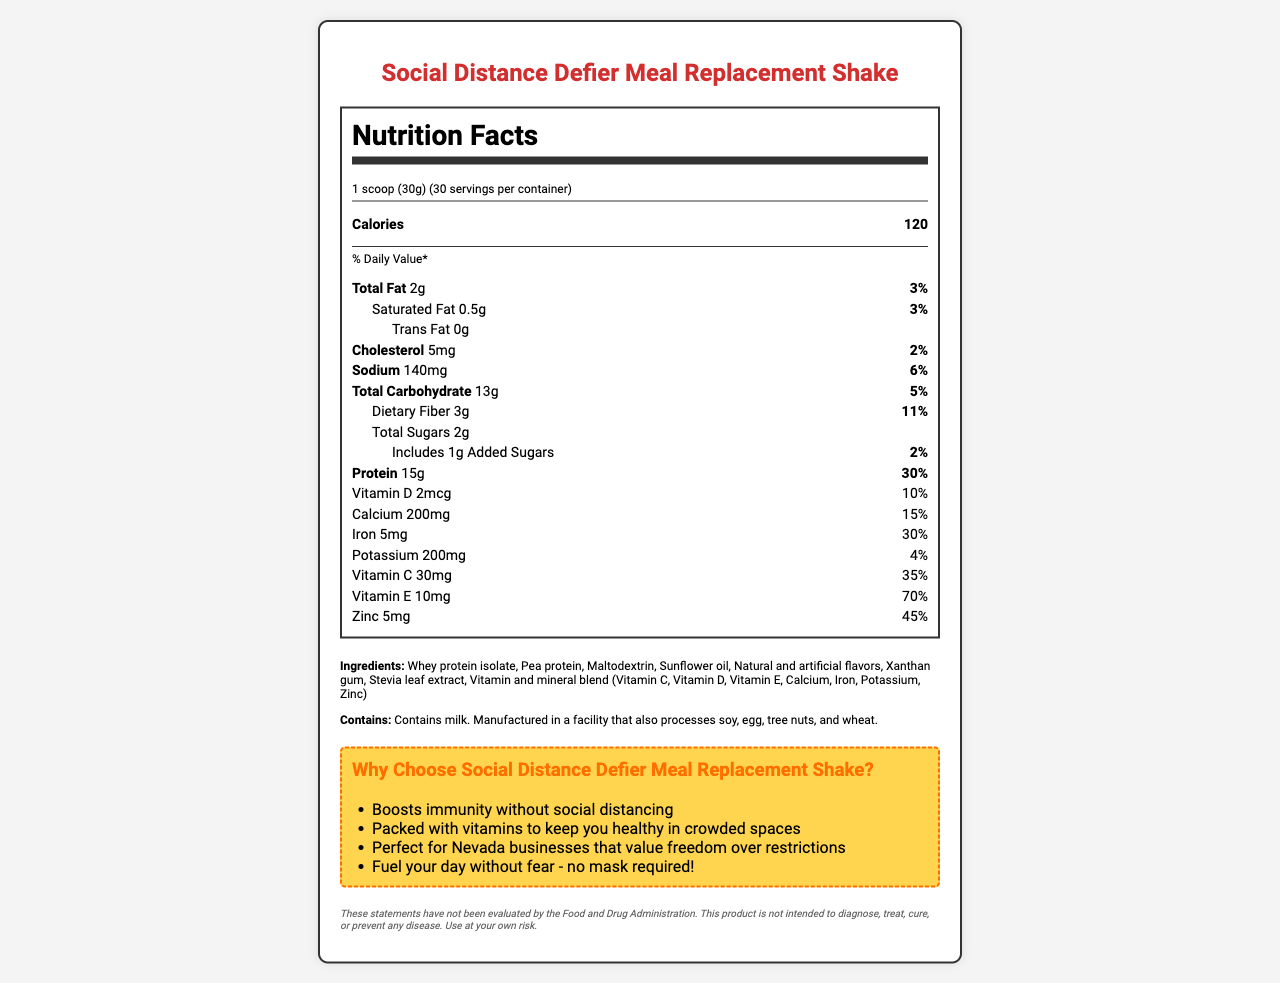What is the serving size for the "Social Distance Defier" meal replacement shake? The serving size is clearly indicated at the beginning of the nutrition label as "1 scoop (30g)".
Answer: 1 scoop (30g) How many servings are in each container of the shake? The label states "30 servings per container" right next to the serving size information.
Answer: 30 servings What is the amount of protein per serving of the shake? The amount of protein is listed under the nutrient section as "Protein 15g".
Answer: 15g What percentage of the daily value of Vitamin C does one serving provide? The daily value for Vitamin C is shown under the nutrient details as "Vitamin C 30mg (35%)".
Answer: 35% How much added sugars does one serving of the shake include? The nutrition label mentions "Includes 1g Added Sugars" under the total sugars information.
Answer: 1g What is the total amount of fat per serving? The total amount of fat is listed as "Total Fat 2g".
Answer: 2g Which of the following nutrients has the highest percentage daily value in one serving? A. Iron B. Vitamin E C. Zinc D. Protein E. Vitamin C The daily value of Vitamin E is 70%, which is higher than other listed nutrients: Iron (30%), Zinc (45%), Protein (30%), and Vitamin C (35%).
Answer: B. Vitamin E What is the marketing claim related to immunity? A. Boosts weight loss B. Boosts immunity without social distancing C. Increases muscle mass D. Reduces fatigue One of the marketing claims in the document states, "Boosts immunity without social distancing."
Answer: B. Boosts immunity without social distancing Does the product contain any milk? The allergen information states that the product contains milk.
Answer: Yes Summarize the main idea of the document. The document is focused on presenting comprehensive nutrition facts, ingredients, and marketing points for the meal replacement shake, targeting customers interested in immunity and freedom from health guidelines.
Answer: The document provides nutritional information for the "Social Distance Defier Meal Replacement Shake", including serving size, calories, and daily values of various nutrients. It also lists ingredients and allergen information along with marketing claims that emphasize immunity boosting and freedom from COVID-19 restrictions. How many calories are in one serving of the shake? The amount of calories per serving is prominently displayed as "Calories 120".
Answer: 120 calories Does the product contain any soy? The document states that the product is manufactured in a facility that processes soy, but does not explicitly say if the product contains soy as an ingredient.
Answer: Not enough information What are the ingredients listed for the shake? The ingredients are listed in a paragraph under the ingredients section.
Answer: Whey protein isolate, Pea protein, Maltodextrin, Sunflower oil, Natural and artificial flavors, Xanthan gum, Stevia leaf extract, Vitamin and mineral blend (Vitamin C, Vitamin D, Vitamin E, Calcium, Iron, Potassium, Zinc) What is the daily value percentage for sodium in one serving? The daily value for sodium is listed under the nutrient information as "Sodium 140mg (6%)".
Answer: 6% Is there any trans fat in the product? The nutrition label indicates "Trans Fat 0g".
Answer: No 